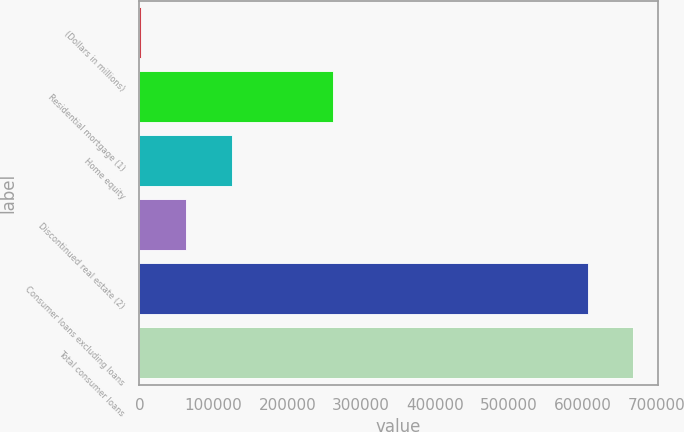<chart> <loc_0><loc_0><loc_500><loc_500><bar_chart><fcel>(Dollars in millions)<fcel>Residential mortgage (1)<fcel>Home equity<fcel>Discontinued real estate (2)<fcel>Consumer loans excluding loans<fcel>Total consumer loans<nl><fcel>2011<fcel>262290<fcel>124699<fcel>62748.3<fcel>607194<fcel>667931<nl></chart> 